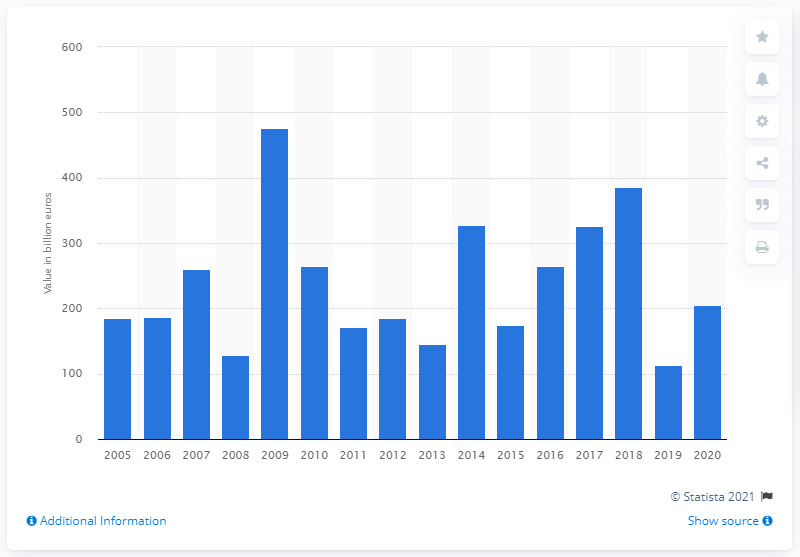Point out several critical features in this image. The largest amount of euro banknotes were produced in 2009. The total value of Euro banknotes produced in 2020 was 205.01.. 